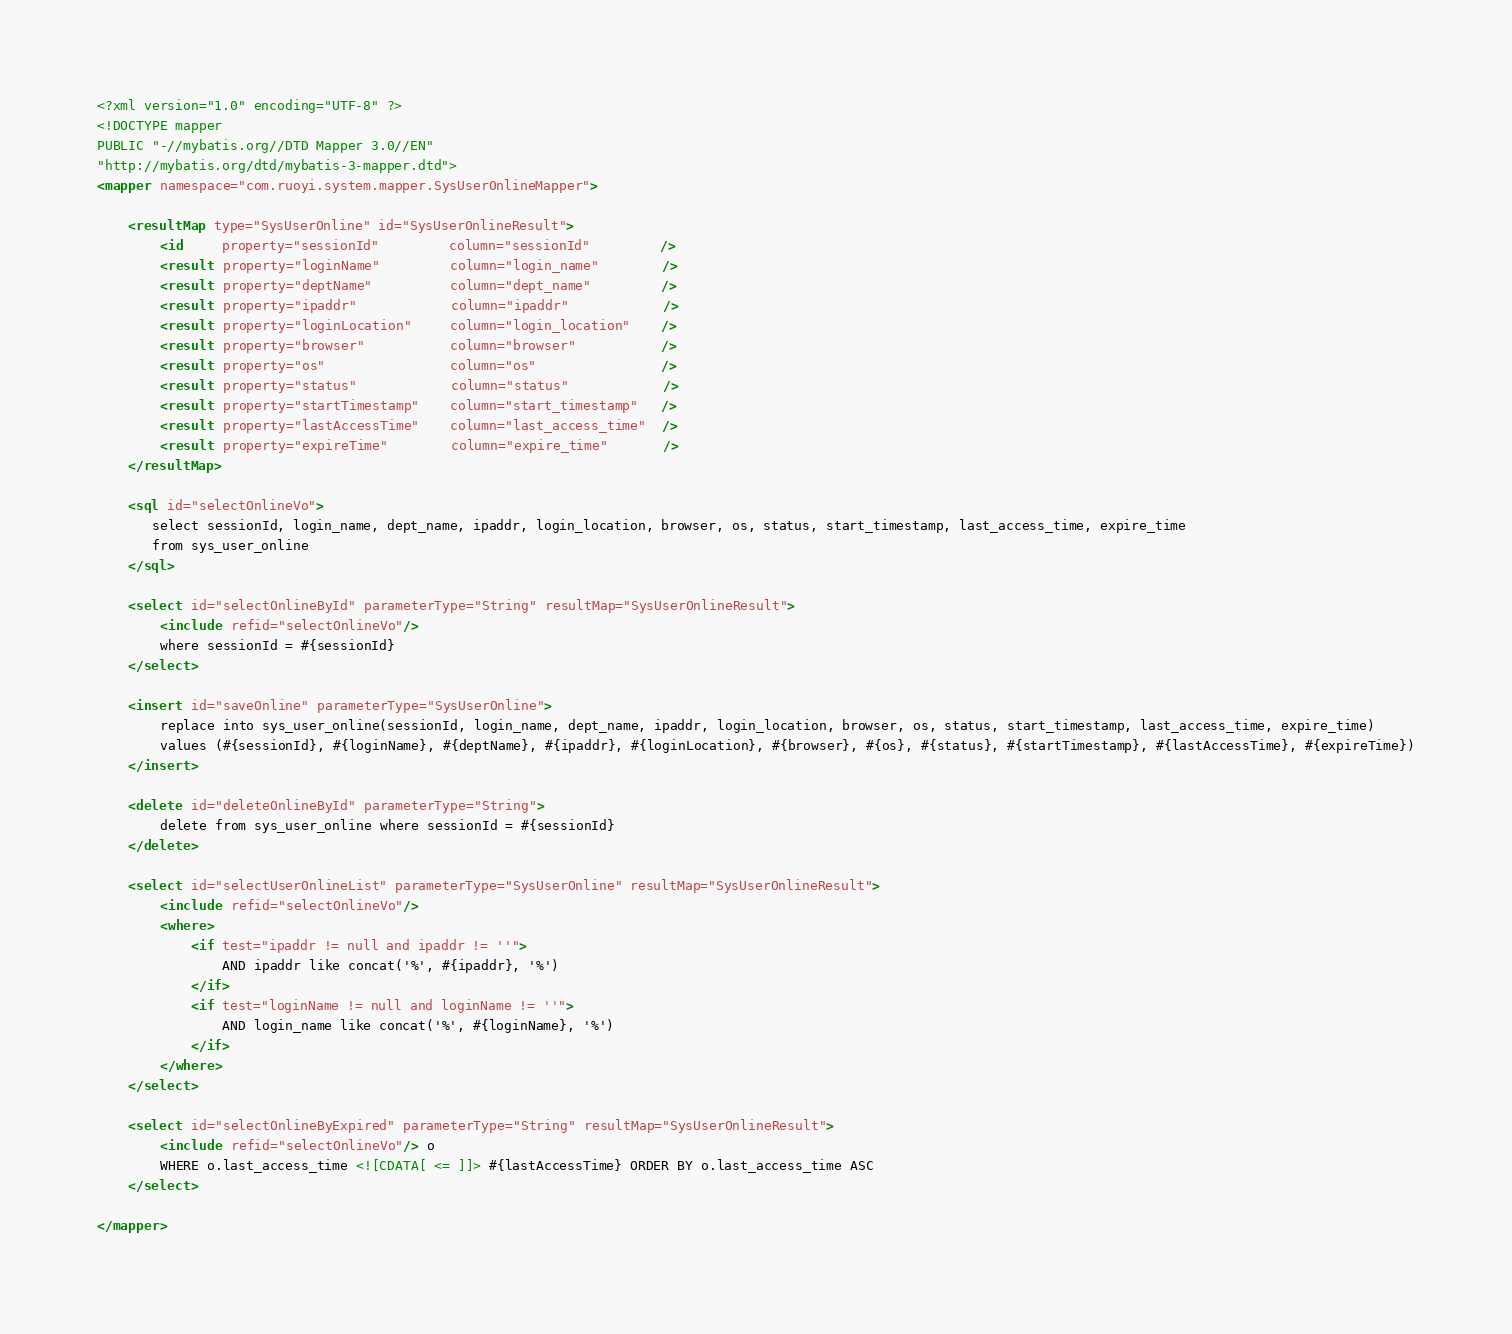<code> <loc_0><loc_0><loc_500><loc_500><_XML_><?xml version="1.0" encoding="UTF-8" ?>
<!DOCTYPE mapper
PUBLIC "-//mybatis.org//DTD Mapper 3.0//EN"
"http://mybatis.org/dtd/mybatis-3-mapper.dtd">
<mapper namespace="com.ruoyi.system.mapper.SysUserOnlineMapper">

	<resultMap type="SysUserOnline" id="SysUserOnlineResult">
		<id     property="sessionId"         column="sessionId"         />
		<result property="loginName"         column="login_name"        />
		<result property="deptName"          column="dept_name"         />
		<result property="ipaddr"            column="ipaddr"            />
		<result property="loginLocation"     column="login_location"    />
		<result property="browser"           column="browser"           />
		<result property="os"                column="os"                />
		<result property="status"            column="status"            />
		<result property="startTimestamp"    column="start_timestamp"   />
		<result property="lastAccessTime"    column="last_access_time"  />
		<result property="expireTime"        column="expire_time"       />
	</resultMap>
	
	<sql id="selectOnlineVo">
       select sessionId, login_name, dept_name, ipaddr, login_location, browser, os, status, start_timestamp, last_access_time, expire_time 
	   from sys_user_online
    </sql>
    
	<select id="selectOnlineById" parameterType="String" resultMap="SysUserOnlineResult">
		<include refid="selectOnlineVo"/>
		where sessionId = #{sessionId}
	</select>

	<insert id="saveOnline" parameterType="SysUserOnline">
		replace into sys_user_online(sessionId, login_name, dept_name, ipaddr, login_location, browser, os, status, start_timestamp, last_access_time, expire_time)
        values (#{sessionId}, #{loginName}, #{deptName}, #{ipaddr}, #{loginLocation}, #{browser}, #{os}, #{status}, #{startTimestamp}, #{lastAccessTime}, #{expireTime})
	</insert>
	
 	<delete id="deleteOnlineById" parameterType="String">
 		delete from sys_user_online where sessionId = #{sessionId}
 	</delete>
 	
 	<select id="selectUserOnlineList" parameterType="SysUserOnline" resultMap="SysUserOnlineResult">
		<include refid="selectOnlineVo"/>
		<where>
			<if test="ipaddr != null and ipaddr != ''">
				AND ipaddr like concat('%', #{ipaddr}, '%')
			</if>
			<if test="loginName != null and loginName != ''">
				AND login_name like concat('%', #{loginName}, '%')
			</if>
		</where>
	</select>
	
	<select id="selectOnlineByExpired" parameterType="String" resultMap="SysUserOnlineResult">
		<include refid="selectOnlineVo"/> o 
		WHERE o.last_access_time <![CDATA[ <= ]]> #{lastAccessTime} ORDER BY o.last_access_time ASC
	</select>

</mapper> </code> 